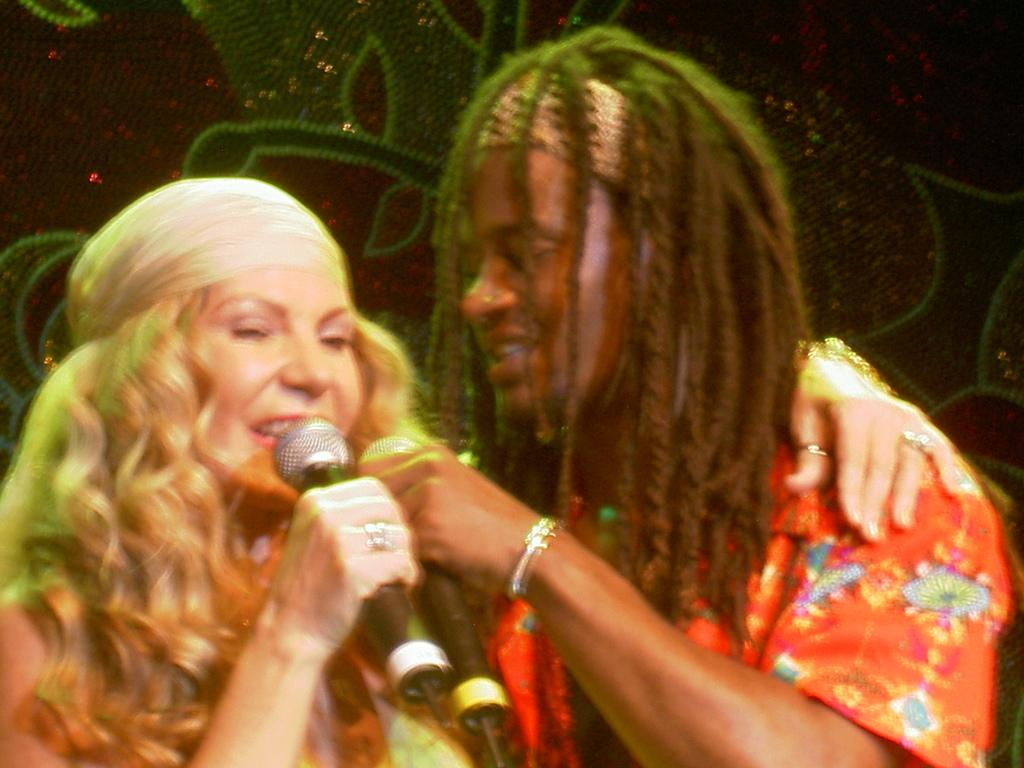Who or what is present in the image? There are people in the image. What are the people doing in the image? The people are holding microphones. Can you describe the appearance of one of the people in the image? One person is wearing a red dress. How would you describe the quality of the image? The image is slightly blurry. What type of silk is being used to make the porter's uniform in the image? There is no porter or silk mentioned in the image, and therefore no such uniform can be observed. How many clovers are visible on the person wearing the red dress in the image? There are no clovers visible on the person wearing the red dress in the image. 